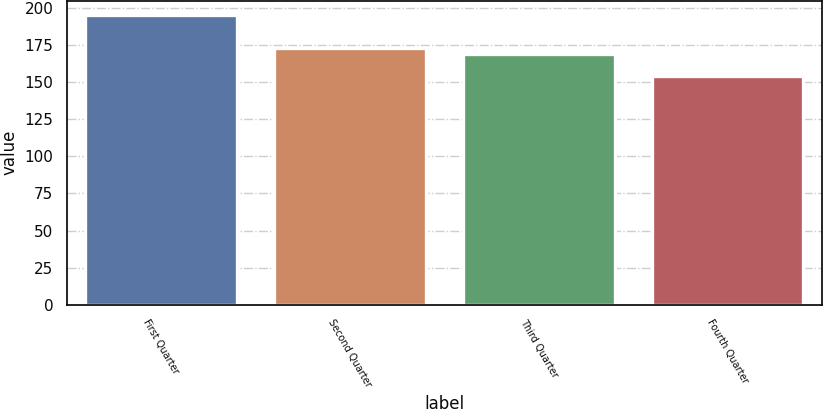Convert chart to OTSL. <chart><loc_0><loc_0><loc_500><loc_500><bar_chart><fcel>First Quarter<fcel>Second Quarter<fcel>Third Quarter<fcel>Fourth Quarter<nl><fcel>195.41<fcel>173.44<fcel>168.94<fcel>153.99<nl></chart> 